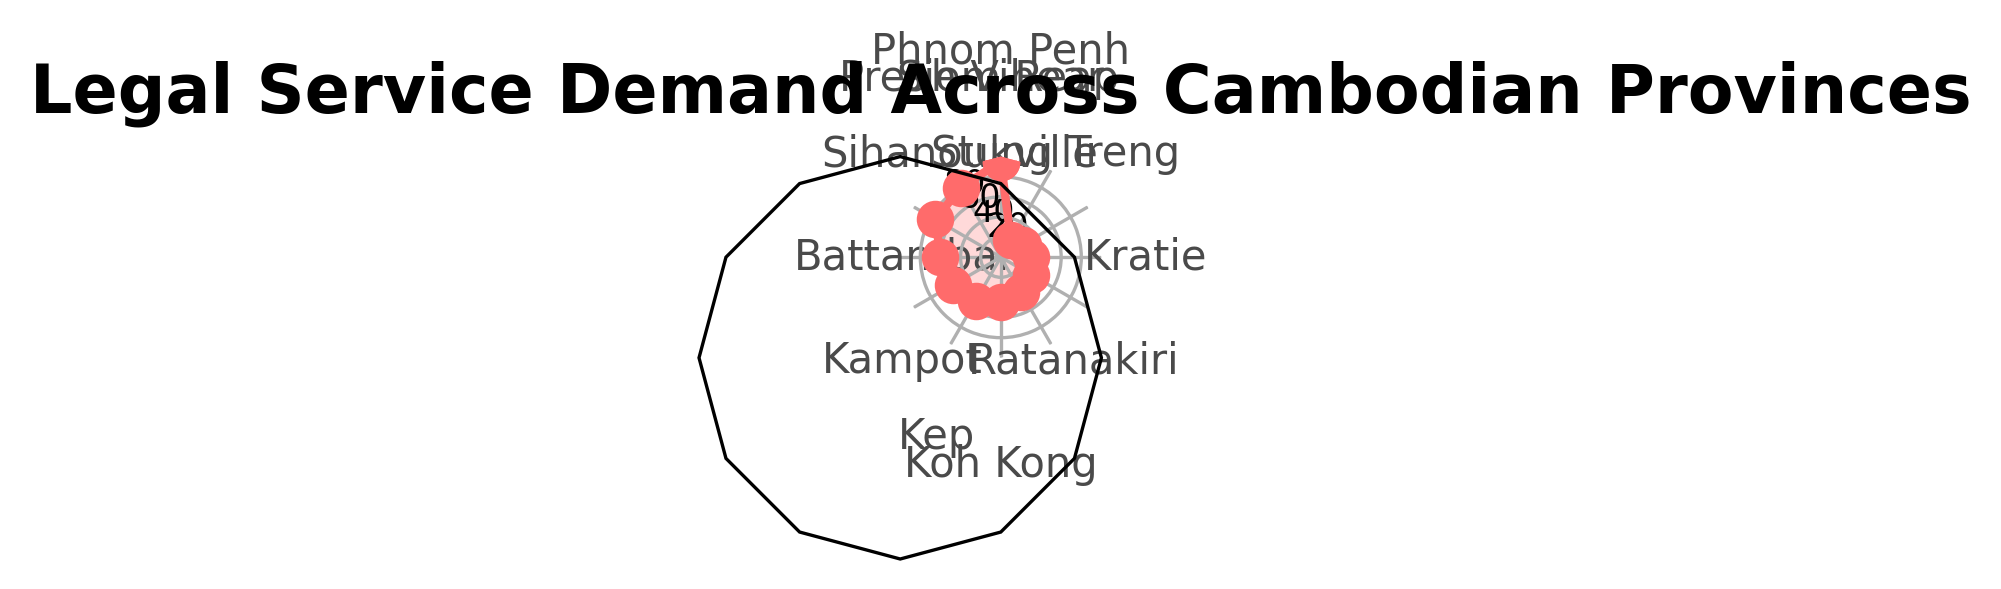What's the highest legal service demand among the provinces? By observing the radar chart, the vertex with the highest value corresponds to Phnom Penh. The demand value at this point is 95.
Answer: 95 Which province has the lowest legal service demand? The province at the vertex with the smallest value is Preah Vihear, with a demand of 20.
Answer: Preah Vihear Compare the legal service demand between Battambang and Kampot. Which province has a higher demand? In the radar chart, Battambang has a demand at 60 and Kampot has a demand at 55. Since 60 is greater than 55, Battambang has a higher demand.
Answer: Battambang What's the average legal service demand across all provinces? Sum the demands of all provinces and divide by the number of provinces: (95 + 80 + 75 + 60 + 55 + 50 + 45 + 40 + 35 + 30 + 25 + 20) / 12 = 610 / 12 = 50.833.
Answer: 50.83 What's the sum of the legal service demand for Phnom Penh, Siem Reap, and Sihanoukville? Add the demand values of the three provinces: 95 (Phnom Penh) + 80 (Siem Reap) + 75 (Sihanoukville) = 250.
Answer: 250 Is the demand in Kampot higher than in Koh Kong? Kampot has a demand of 55, while Koh Kong has a demand of 45. Since 55 is greater than 45, Kampot's demand is higher.
Answer: Yes Which province is the third highest in legal service demand? The third highest value in the radar chart is 75, which corresponds to Sihanoukville.
Answer: Sihanoukville How does the combined demand of Kep and Mondulkiri compare to Battambang? Add the demand values of Kep (50) and Mondulkiri (40): 50 + 40 = 90. Compare this sum to Battambang's demand of 60. 90 is greater than 60.
Answer: Higher What is the difference in legal service demand between Siem Reap and Kratie? Subtract the demand of Kratie (30) from Siem Reap (80): 80 - 30 = 50.
Answer: 50 How many provinces have a demand of 50 or more? Count the provinces with demand values 50 or more: Phnom Penh (95), Siem Reap (80), Sihanoukville (75), Battambang (60), Kampot (55), and Kep (50). This gives 6 provinces.
Answer: 6 